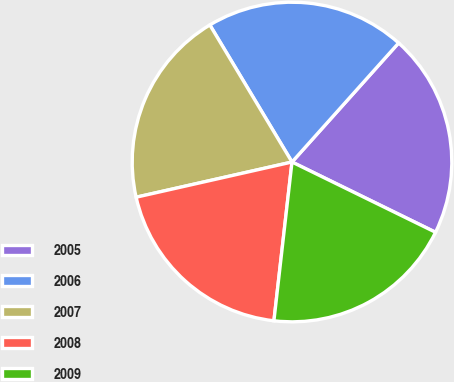Convert chart to OTSL. <chart><loc_0><loc_0><loc_500><loc_500><pie_chart><fcel>2005<fcel>2006<fcel>2007<fcel>2008<fcel>2009<nl><fcel>20.62%<fcel>20.22%<fcel>19.94%<fcel>19.66%<fcel>19.56%<nl></chart> 